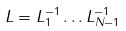<formula> <loc_0><loc_0><loc_500><loc_500>L = L _ { 1 } ^ { - 1 } \dots L _ { N - 1 } ^ { - 1 }</formula> 